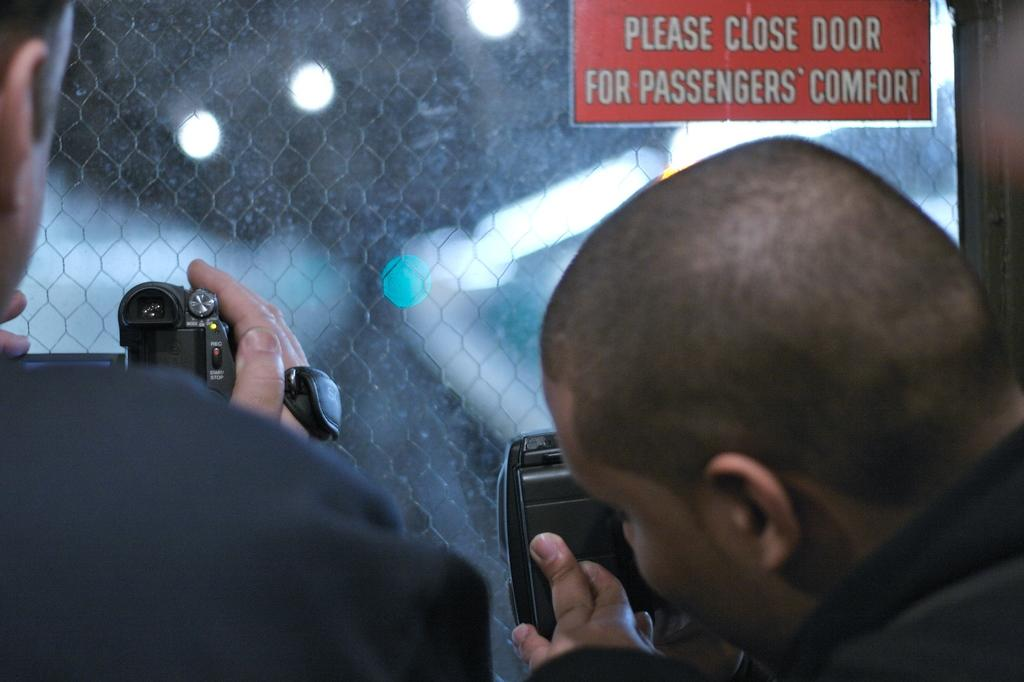How many people are in the image? There are two persons in the image. What are the persons holding in the image? The persons are holding a camera. What is in front of the persons? The persons are in front of a glass. What is associated with the glass? There is a board associated with the glass. Can you see the baby's feet in the image? There is no baby present in the image, so it is not possible to see the baby's feet. 